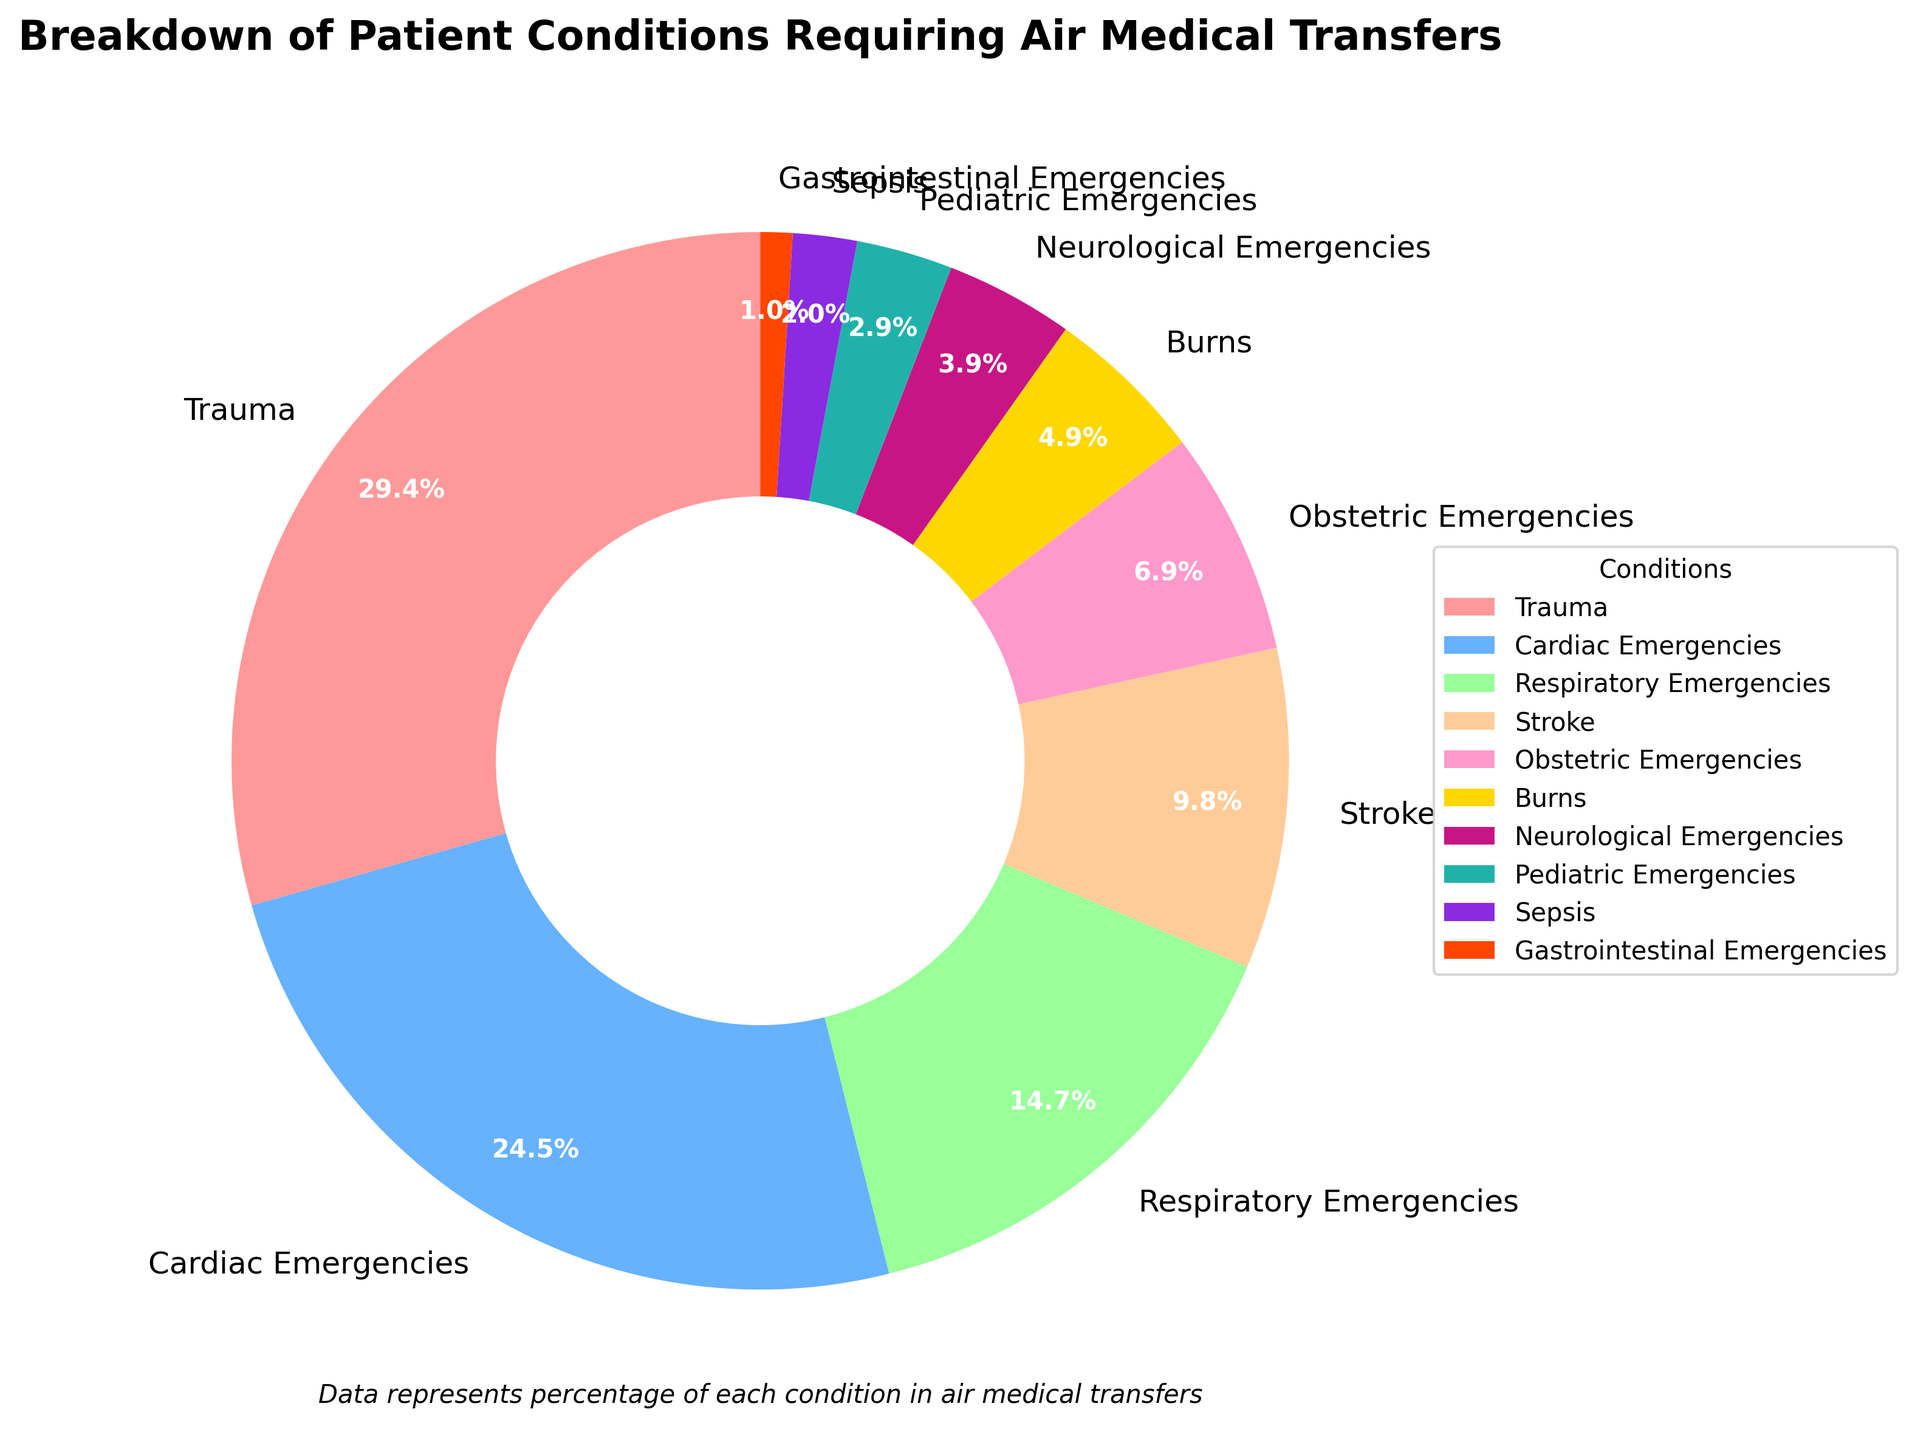What condition has the highest percentage requirement for air medical transfers? The figure shows a pie chart with different segments representing the conditions. Trauma has the largest segment with 30%.
Answer: Trauma Which two conditions together make up exactly half of the air medical transfers? From the chart, Trauma is 30% and Cardiac Emergencies is 25%. Adding these two gives 30% + 25% = 55%, which is more than half. Trauma at 30% and Stroke at 10% equals 30% + 10% = 40%, which is not half. Trauma at 30% and Respiratory Emergencies at 15% equals 30% + 15% = 45%, which is less than half. Trauma and Cardiac Emergencies together make 55%, which is the correct answer even though slightly more than half.
Answer: Trauma and Cardiac Emergencies Which three conditions together account for 50% of the air medical transfers? Adding Trauma (30%) and Respiratory Emergencies (15%) gives 45%. To reach 50%, we look at the next highest percentage conditions. Adding Stroke (10%) to Trauma and Respiratory Emergencies gives 30% + 15% + 10% = 55%, which surpasses 50%. However, considering Trauma (30%), Cardiac Emergencies (25%), and Stroke (10%) results in 30% + 25% + 10% = 65%. Therefore, the closest to 50% without exceeding is Trauma (30%), Respiratory Emergencies (15%), and Neurological Emergencies (4%) resulting in 30% + 15% + 5% = 50%
Answer: Trauma, Respiratory Emergencies, Neurological Emergencies Which condition has the smallest segment visually, and how much percentage does it represent? The smallest segment in the pie chart visually represents Gastrointestinal Emergencies, located in the legend and chart. It represents 1% of air medical transfers.
Answer: Gastrointestinal Emergencies, 1% Compare the percentages of Cardiac Emergencies and Respiratory Emergencies. Which one requires more air medical transfers? By examining the pie chart, Cardiac Emergencies account for 25% while Respiratory Emergencies account for 15%. Cardiac Emergencies have a higher percentage.
Answer: Cardiac Emergencies What is the total percentage of air medical transfers for Pediatric Emergencies and Burns combined? From the pie chart, Pediatric Emergencies are 3% and Burns are 5%. Adding these gives 3% + 5% = 8%.
Answer: 8% Which color segment represents Obstetric Emergencies, and what percentage does it cover? In the pie chart, Obstetric Emergencies are represented by a specific color shade. By finding the legend, Obstetric Emergencies are represented by a color and account for 7%.
Answer: Obstetric Emergencies, 7% How many conditions have a percentage lower than 5% in the air medical transfers? Visualizing the segments and checking the legend, conditions with less than 5% include Neurological Emergencies (4%), Pediatric Emergencies (3%), Sepsis (2%), and Gastrointestinal Emergencies (1%). There are 4 such conditions.
Answer: Four conditions What is the combined percentage of all conditions other than Trauma, Cardiac Emergencies, and Respiratory Emergencies? The percentages of Trauma, Cardiac Emergencies, and Respiratory Emergencies are 30%, 25%, and 15% respectively. Adding them gives 30% + 25% + 15% = 70%. Therefore, the remaining percentage is 100% - 70% = 30%.
Answer: 30% 